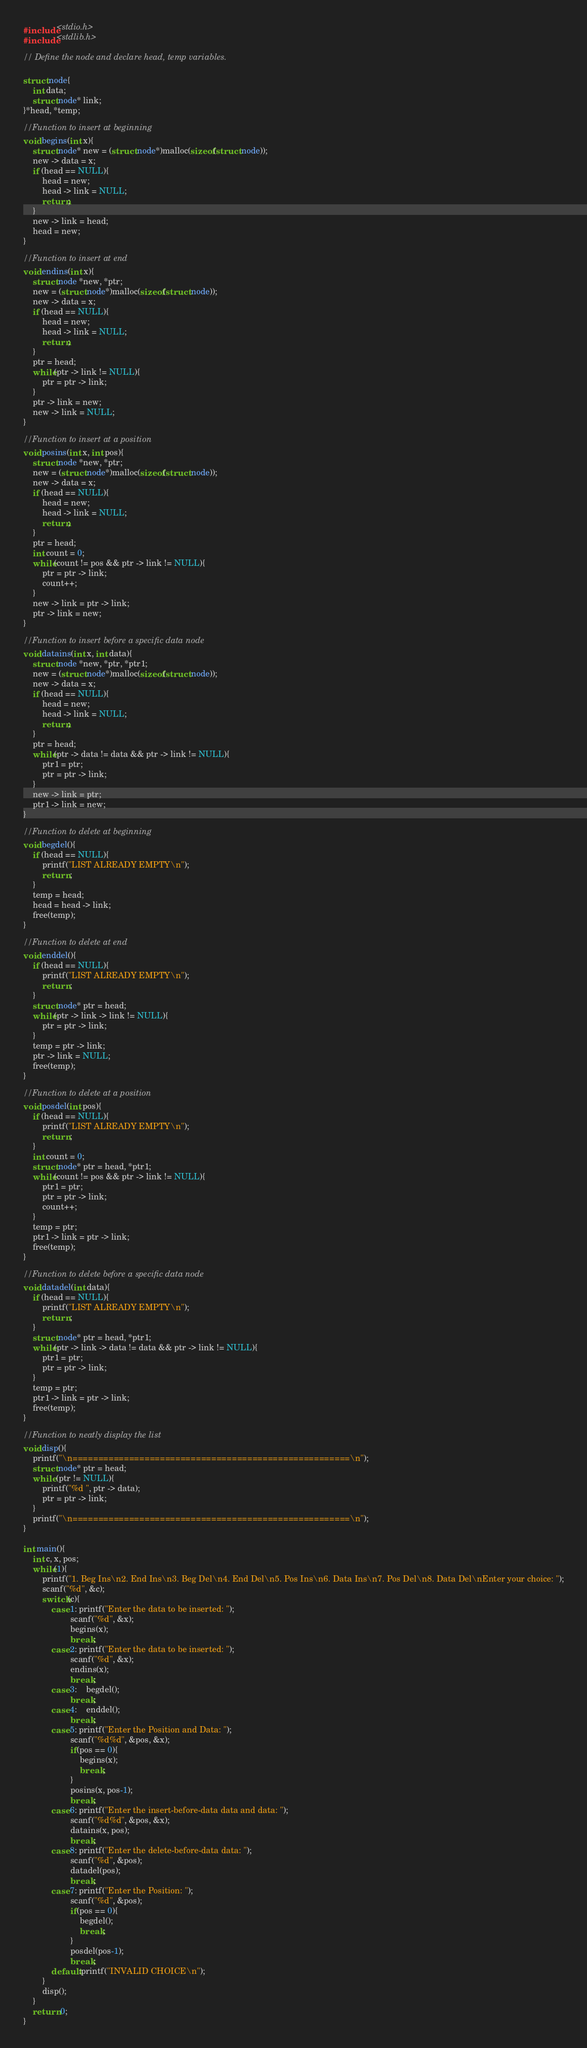<code> <loc_0><loc_0><loc_500><loc_500><_C_>#include<stdio.h>
#include<stdlib.h>

// Define the node and declare head, temp variables.

struct node{
	int data;
	struct node* link;
}*head, *temp;

//Function to insert at beginning
void begins(int x){
	struct node* new = (struct node*)malloc(sizeof(struct node));
	new -> data = x;
	if (head == NULL){
		head = new;
		head -> link = NULL;
		return;
	}
	new -> link = head;
	head = new;
}

//Function to insert at end
void endins(int x){
	struct node *new, *ptr;
	new = (struct node*)malloc(sizeof(struct node));
	new -> data = x;
	if (head == NULL){
		head = new;
		head -> link = NULL;
		return;
	}
	ptr = head;
	while(ptr -> link != NULL){
		ptr = ptr -> link;
	}
	ptr -> link = new;
	new -> link = NULL;
}

//Function to insert at a position
void posins(int x, int pos){
	struct node *new, *ptr;
	new = (struct node*)malloc(sizeof(struct node));
	new -> data = x;
	if (head == NULL){
		head = new;
		head -> link = NULL;
		return;
	}
	ptr = head;
	int count = 0;
	while(count != pos && ptr -> link != NULL){
		ptr = ptr -> link;
		count++;
	}
	new -> link = ptr -> link;
	ptr -> link = new;
}

//Function to insert before a specific data node
void datains(int x, int data){
	struct node *new, *ptr, *ptr1;
	new = (struct node*)malloc(sizeof(struct node));
	new -> data = x;
	if (head == NULL){
		head = new;
		head -> link = NULL;
		return;
	}
	ptr = head;
	while(ptr -> data != data && ptr -> link != NULL){
		ptr1 = ptr;
		ptr = ptr -> link;
	}
	new -> link = ptr;
	ptr1 -> link = new;
}

//Function to delete at beginning
void begdel(){
	if (head == NULL){
		printf("LIST ALREADY EMPTY\n");
		return ;
	}
	temp = head;
	head = head -> link;
	free(temp);
}

//Function to delete at end
void enddel(){
	if (head == NULL){
		printf("LIST ALREADY EMPTY\n");
		return ;
	}
	struct node* ptr = head;
	while(ptr -> link -> link != NULL){
		ptr = ptr -> link;
	}
	temp = ptr -> link;
	ptr -> link = NULL;
	free(temp);
}

//Function to delete at a position
void posdel(int pos){
	if (head == NULL){
		printf("LIST ALREADY EMPTY\n");
		return ;
	}
	int count = 0;
	struct node* ptr = head, *ptr1;
	while(count != pos && ptr -> link != NULL){
		ptr1 = ptr;
		ptr = ptr -> link;
		count++;
	}
	temp = ptr;
	ptr1 -> link = ptr -> link;
	free(temp);
}

//Function to delete before a specific data node
void datadel(int data){
	if (head == NULL){
		printf("LIST ALREADY EMPTY\n");
		return ;
	}
	struct node* ptr = head, *ptr1;
	while(ptr -> link -> data != data && ptr -> link != NULL){
		ptr1 = ptr;
		ptr = ptr -> link;
	}
	temp = ptr;
	ptr1 -> link = ptr -> link;
	free(temp);
}

//Function to neatly display the list
void disp(){
	printf("\n======================================================\n");
	struct node* ptr = head;
	while (ptr != NULL){
		printf("%d ", ptr -> data);
		ptr = ptr -> link;
	}
	printf("\n======================================================\n");
}

int main(){
	int c, x, pos;
	while(1){
		printf("1. Beg Ins\n2. End Ins\n3. Beg Del\n4. End Del\n5. Pos Ins\n6. Data Ins\n7. Pos Del\n8. Data Del\nEnter your choice: ");
		scanf("%d", &c);
		switch(c){
			case 1: printf("Enter the data to be inserted: ");
					scanf("%d", &x);
					begins(x);
					break;
			case 2: printf("Enter the data to be inserted: ");
					scanf("%d", &x);
					endins(x);
					break;
			case 3:	begdel();
					break;
			case 4:	enddel();
					break;
			case 5: printf("Enter the Position and Data: ");
					scanf("%d%d", &pos, &x);
					if(pos == 0){
						begins(x);
						break;
					}
					posins(x, pos-1);
					break;
			case 6: printf("Enter the insert-before-data data and data: ");
					scanf("%d%d", &pos, &x);
					datains(x, pos);
					break;
			case 8: printf("Enter the delete-before-data data: ");
					scanf("%d", &pos);
					datadel(pos);
					break;
			case 7: printf("Enter the Position: ");
					scanf("%d", &pos);
					if(pos == 0){
						begdel();
						break;
					}
					posdel(pos-1);
					break;
			default:printf("INVALID CHOICE\n");
		}
		disp();
	}
	return 0;
}
</code> 